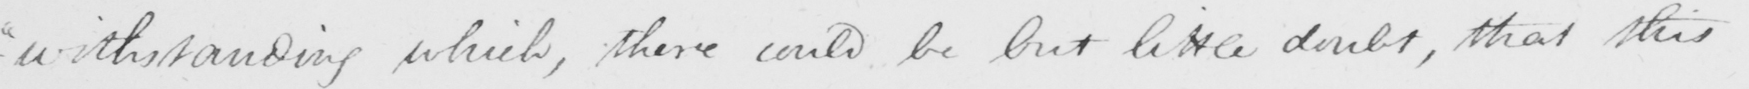What does this handwritten line say? - " withstanding which , there could be but little doubt , that this 